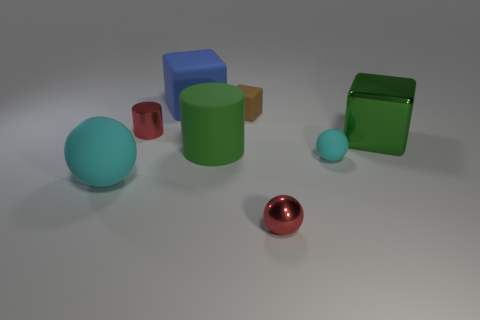There is a large green thing that is the same shape as the big blue matte thing; what material is it?
Your answer should be very brief. Metal. Is the number of tiny metallic objects that are left of the big matte block greater than the number of tiny red metallic objects that are on the left side of the large metallic block?
Ensure brevity in your answer.  No. The big cyan thing that is made of the same material as the large blue object is what shape?
Give a very brief answer. Sphere. How many other things are there of the same shape as the large cyan matte object?
Provide a succinct answer. 2. What is the shape of the tiny shiny thing right of the blue rubber thing?
Your answer should be compact. Sphere. What color is the tiny rubber block?
Provide a succinct answer. Brown. What number of other things are the same size as the red shiny cylinder?
Provide a succinct answer. 3. The red object left of the small red object that is to the right of the metal cylinder is made of what material?
Give a very brief answer. Metal. Do the red sphere and the matte ball on the right side of the brown rubber cube have the same size?
Give a very brief answer. Yes. Is there a big cylinder that has the same color as the big metallic cube?
Make the answer very short. Yes. 